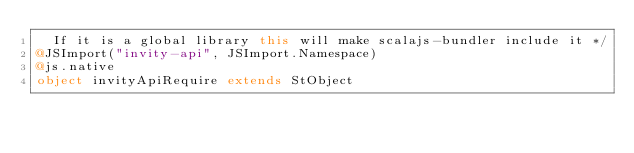Convert code to text. <code><loc_0><loc_0><loc_500><loc_500><_Scala_>  If it is a global library this will make scalajs-bundler include it */
@JSImport("invity-api", JSImport.Namespace)
@js.native
object invityApiRequire extends StObject
</code> 